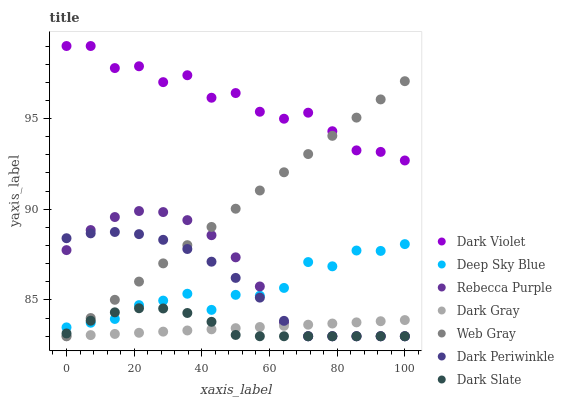Does Dark Gray have the minimum area under the curve?
Answer yes or no. Yes. Does Dark Violet have the maximum area under the curve?
Answer yes or no. Yes. Does Dark Violet have the minimum area under the curve?
Answer yes or no. No. Does Dark Gray have the maximum area under the curve?
Answer yes or no. No. Is Dark Gray the smoothest?
Answer yes or no. Yes. Is Dark Violet the roughest?
Answer yes or no. Yes. Is Dark Violet the smoothest?
Answer yes or no. No. Is Dark Gray the roughest?
Answer yes or no. No. Does Web Gray have the lowest value?
Answer yes or no. Yes. Does Dark Violet have the lowest value?
Answer yes or no. No. Does Dark Violet have the highest value?
Answer yes or no. Yes. Does Dark Gray have the highest value?
Answer yes or no. No. Is Dark Gray less than Dark Violet?
Answer yes or no. Yes. Is Dark Violet greater than Dark Gray?
Answer yes or no. Yes. Does Dark Violet intersect Web Gray?
Answer yes or no. Yes. Is Dark Violet less than Web Gray?
Answer yes or no. No. Is Dark Violet greater than Web Gray?
Answer yes or no. No. Does Dark Gray intersect Dark Violet?
Answer yes or no. No. 